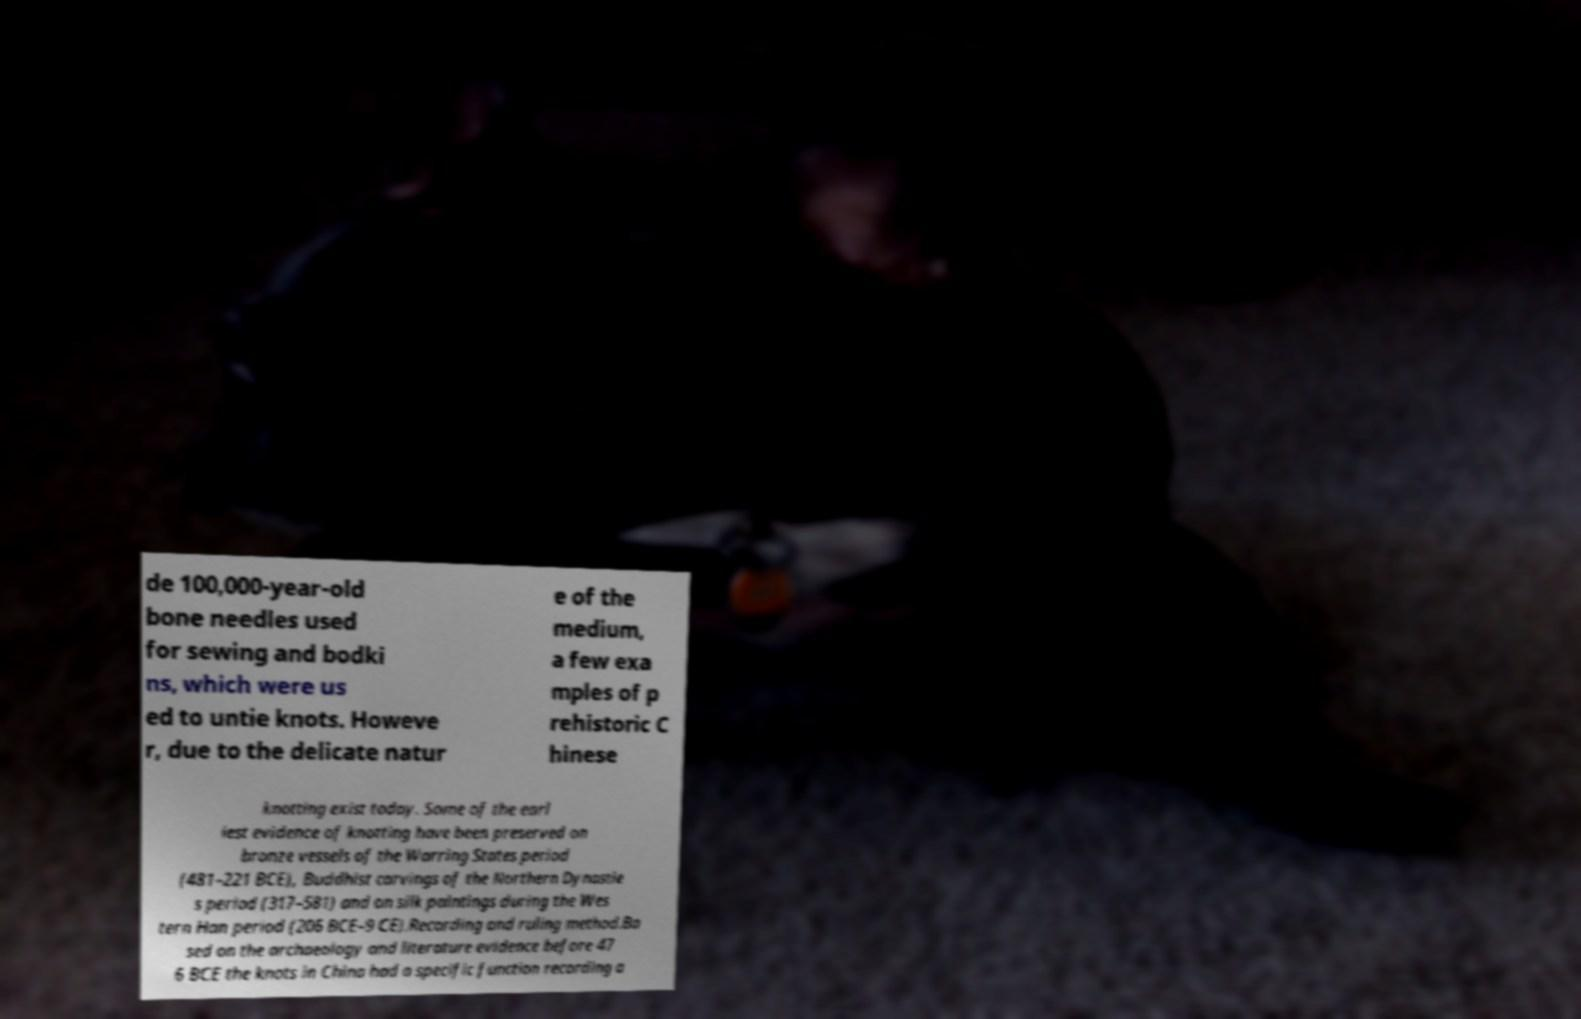Could you extract and type out the text from this image? de 100,000-year-old bone needles used for sewing and bodki ns, which were us ed to untie knots. Howeve r, due to the delicate natur e of the medium, a few exa mples of p rehistoric C hinese knotting exist today. Some of the earl iest evidence of knotting have been preserved on bronze vessels of the Warring States period (481–221 BCE), Buddhist carvings of the Northern Dynastie s period (317–581) and on silk paintings during the Wes tern Han period (206 BCE–9 CE).Recording and ruling method.Ba sed on the archaeology and literature evidence before 47 6 BCE the knots in China had a specific function recording a 